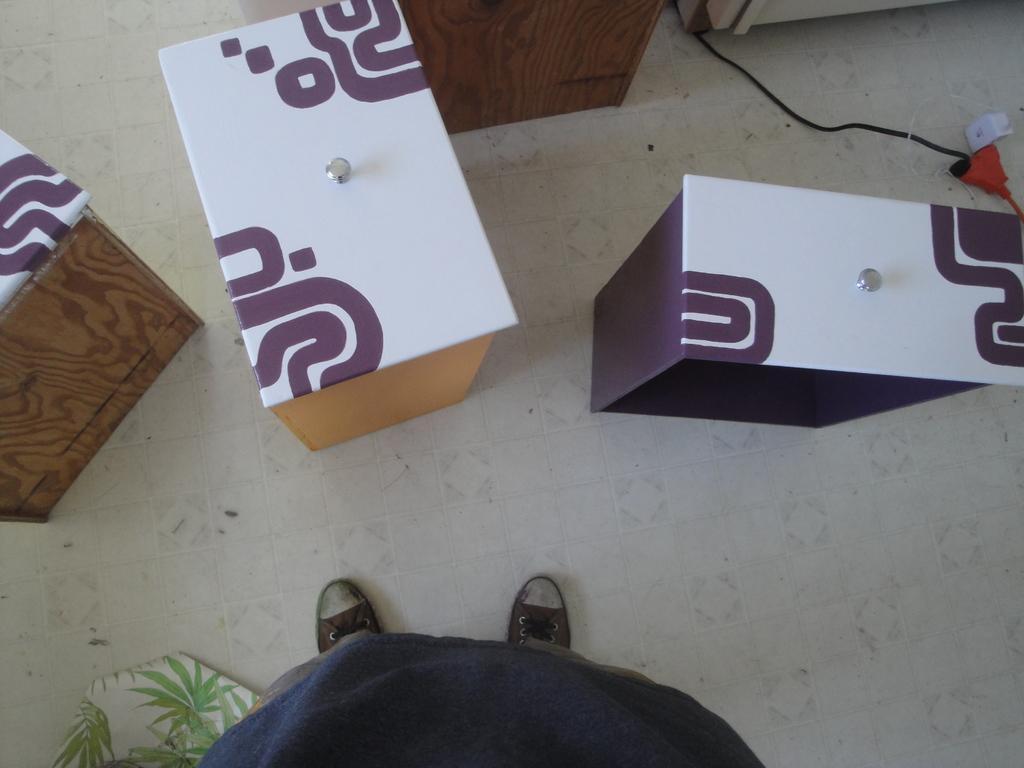Can you describe this image briefly? This image is taken indoors. At the bottom of the image there is a person standing on the floor and there is an object on the floor. In the middle of the image there are a few boxes on the floor and there is a wire. 